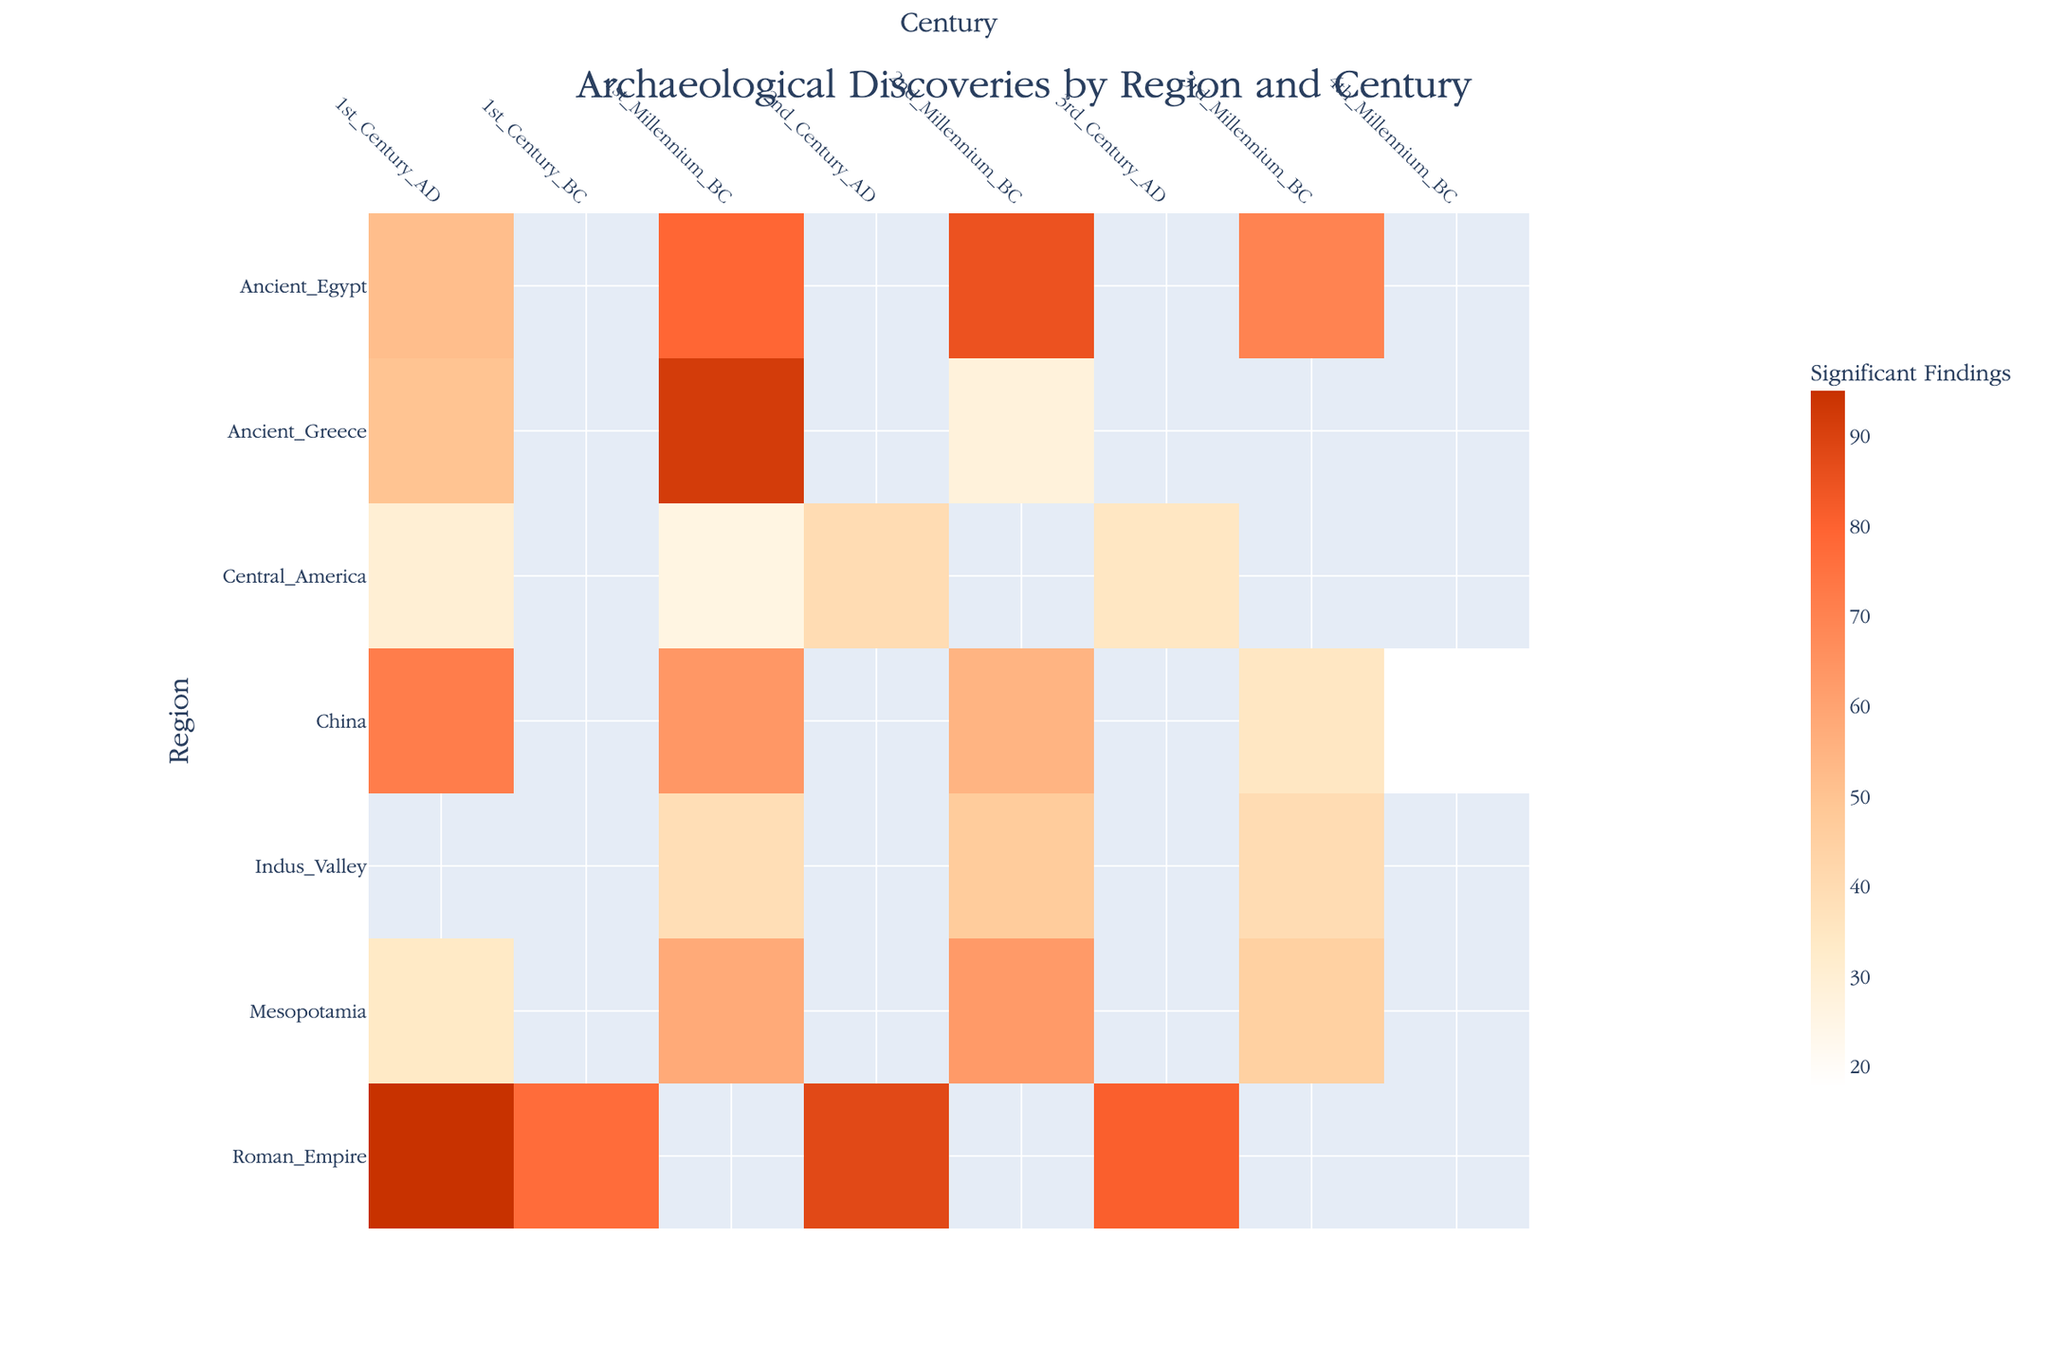Which region had the highest number of significant findings in the 1st Millennium BC? By looking at the heatmap, the region with the darkest color in the 1st Millennium BC offers a hint. Upon examination, Ancient Greece has the darkest shade, corresponding to 92 significant findings.
Answer: Ancient Greece How do the significant findings in the 2nd Millennium BC compare between Mesopotamia and Ancient Egypt? Examine the color intensity for both regions in that specific century. Mesopotamia has lighter shades than Ancient Egypt. Mesopotamia has 63 findings, while Ancient Egypt has 85, indicating Ancient Egypt has more significant findings.
Answer: Ancient Egypt has more Which century had the most archaeological discoveries in the Roman Empire? Identify the century with the darkest shade within the Roman Empire's row on the heatmap. The 1st Century AD stands out with the darkest color, showing 95 findings.
Answer: 1st Century AD Calculate the average significant findings in Ancient Egypt across all centuries presented. Sum the findings in all centuries for Ancient Egypt and divide by the number of centuries. (70 + 85 + 79 + 52) / 4 = 286 / 4 = 71.5.
Answer: 71.5 Is the density of findings in China in the 3rd Millennium BC greater than in the 4th Millennium BC? Compare the color intensities for China in these centuries. The 3rd Millennium BC has a darker shade (35) than the 4th Millennium BC (18).
Answer: Yes Which region and century combination had the lowest number of significant findings? Find the lightest shade on the entire heatmap. China in the 4th Millennium BC is the lightest, with 18 findings.
Answer: China in the 4th Millennium BC What is the difference in significant findings between Mesopotamia in the 2nd Millennium BC and Ancient Greece in the 2nd Millennium BC? Subtract the findings in Ancient Greece from those in Mesopotamia for the 2nd Millennium BC. 63 - 28 = 35.
Answer: 35 Which region has more findings in the 1st Century AD, Ancient Egypt or Central America? Compare the color intensities for both regions in the 1st Century AD. Ancient Egypt's color is darker than that of Central America. Specifically, Ancient Egypt has 52, and Central America has 30.
Answer: Ancient Egypt 